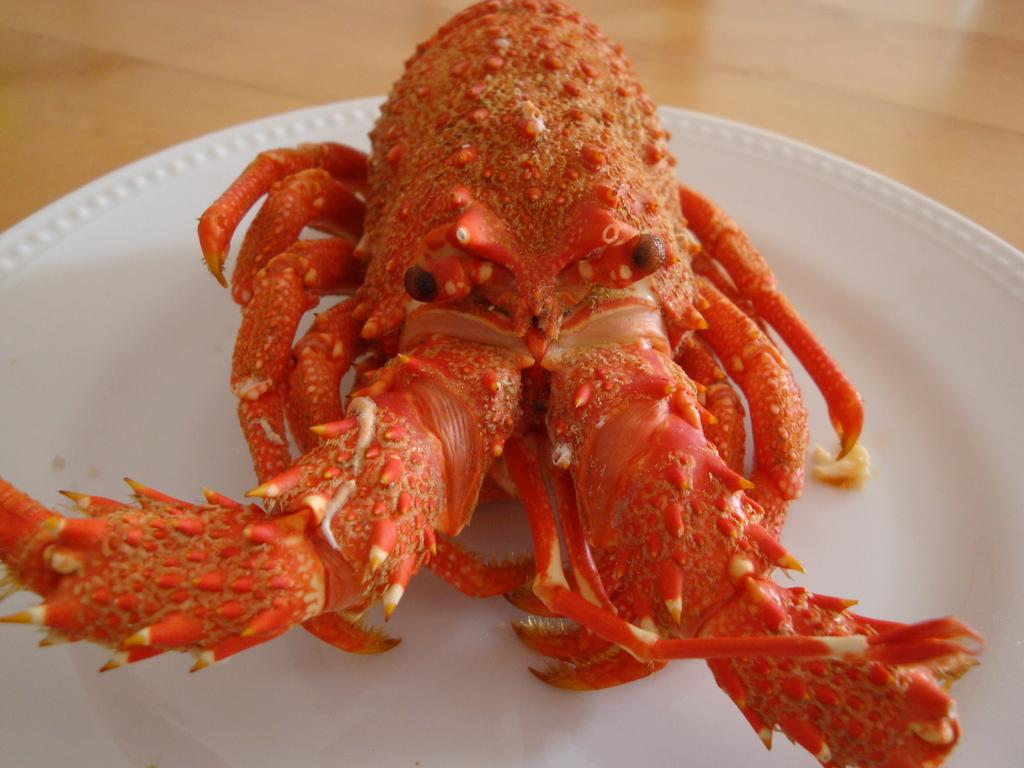What is on the plate that is visible in the image? The plate contains crab. Where is the plate located in the image? The plate is placed on a table. What type of beast can be seen performing an operation on the cushion in the image? There is no beast, operation, or cushion present in the image. 